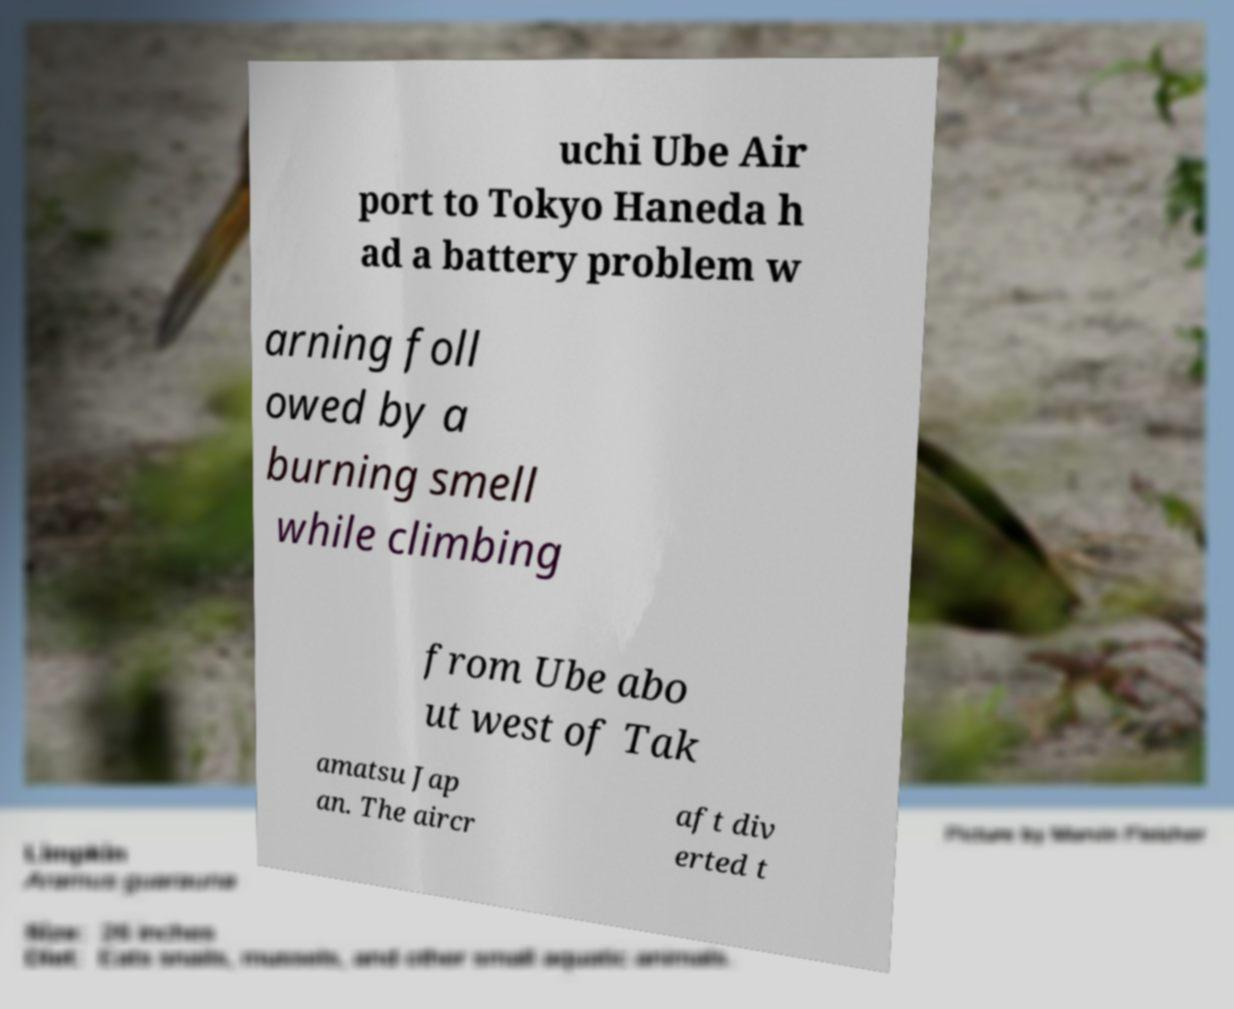For documentation purposes, I need the text within this image transcribed. Could you provide that? uchi Ube Air port to Tokyo Haneda h ad a battery problem w arning foll owed by a burning smell while climbing from Ube abo ut west of Tak amatsu Jap an. The aircr aft div erted t 